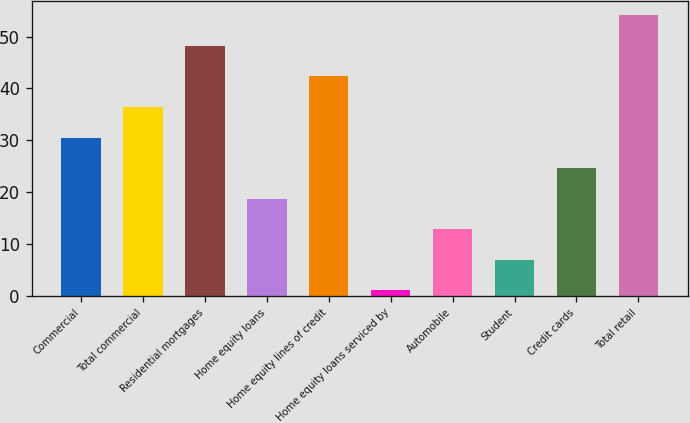Convert chart to OTSL. <chart><loc_0><loc_0><loc_500><loc_500><bar_chart><fcel>Commercial<fcel>Total commercial<fcel>Residential mortgages<fcel>Home equity loans<fcel>Home equity lines of credit<fcel>Home equity loans serviced by<fcel>Automobile<fcel>Student<fcel>Credit cards<fcel>Total retail<nl><fcel>30.5<fcel>36.4<fcel>48.2<fcel>18.7<fcel>42.3<fcel>1<fcel>12.8<fcel>6.9<fcel>24.6<fcel>54.1<nl></chart> 